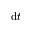Convert formula to latex. <formula><loc_0><loc_0><loc_500><loc_500>d t</formula> 